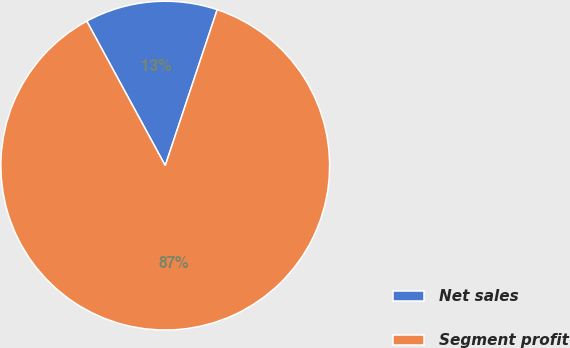Convert chart. <chart><loc_0><loc_0><loc_500><loc_500><pie_chart><fcel>Net sales<fcel>Segment profit<nl><fcel>13.04%<fcel>86.96%<nl></chart> 